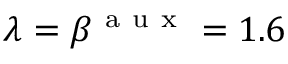<formula> <loc_0><loc_0><loc_500><loc_500>\lambda = \beta ^ { a u x } = 1 . 6</formula> 